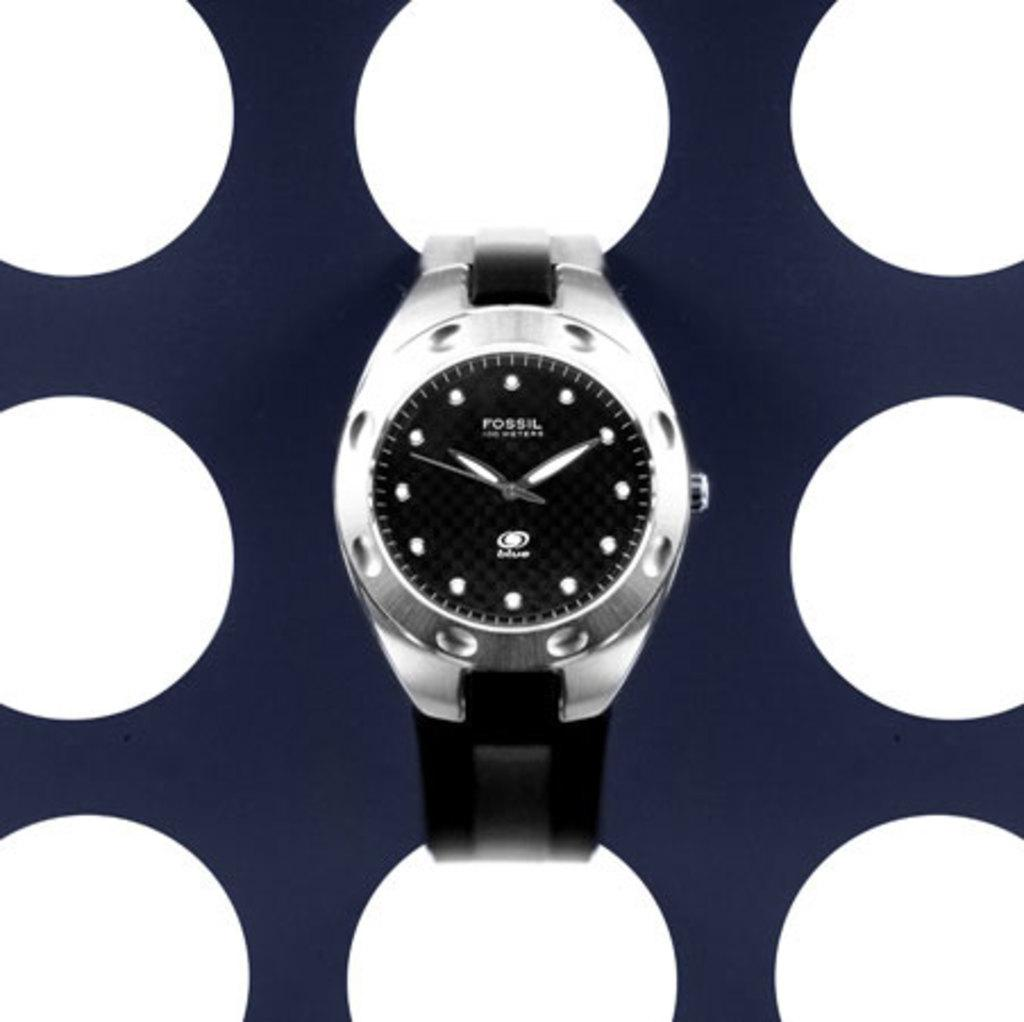<image>
Relay a brief, clear account of the picture shown. A picture of a black and silver Fossil watch. 